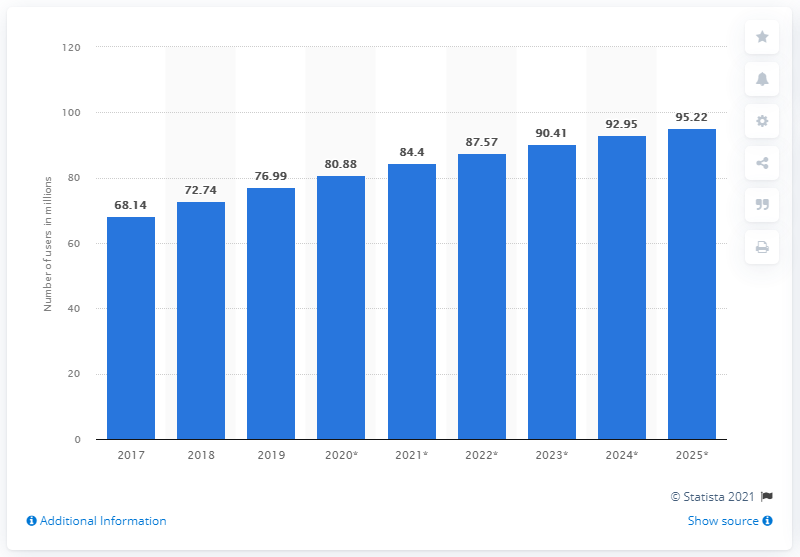Point out several critical features in this image. In 2019, there were 76.99 million Facebook users in Mexico. 